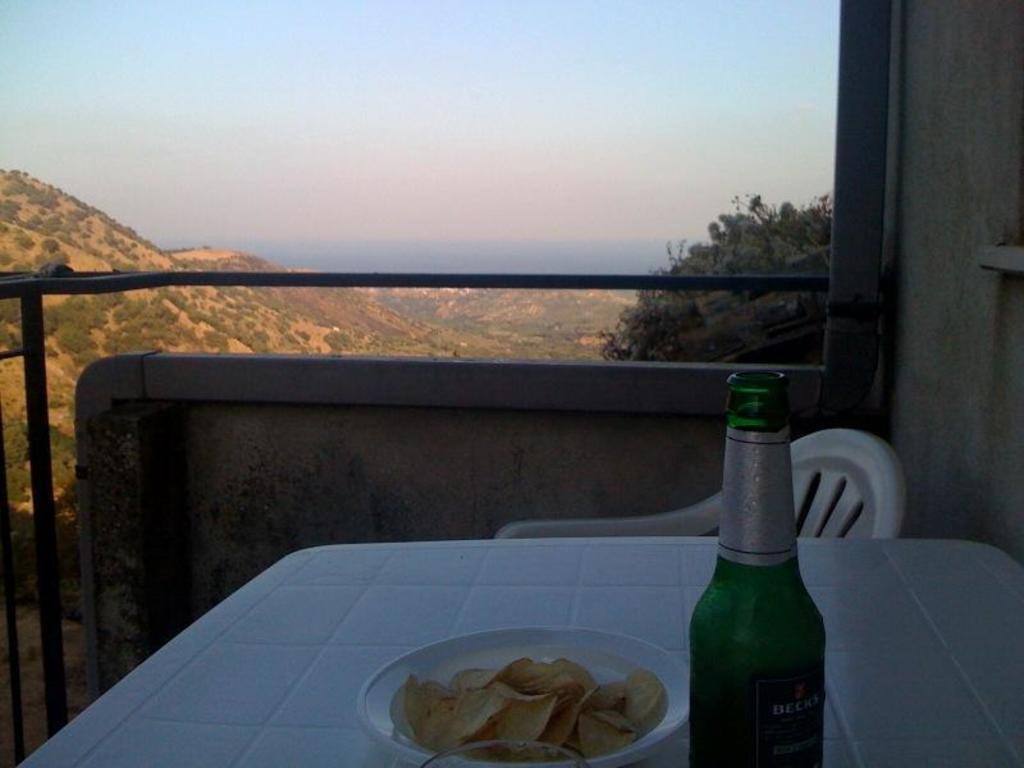Describe this image in one or two sentences. This is table,on the table this plate and the plate contains chips ,this is bottle,this is chair,this is tree and in the background there is sky,this are small plants. 